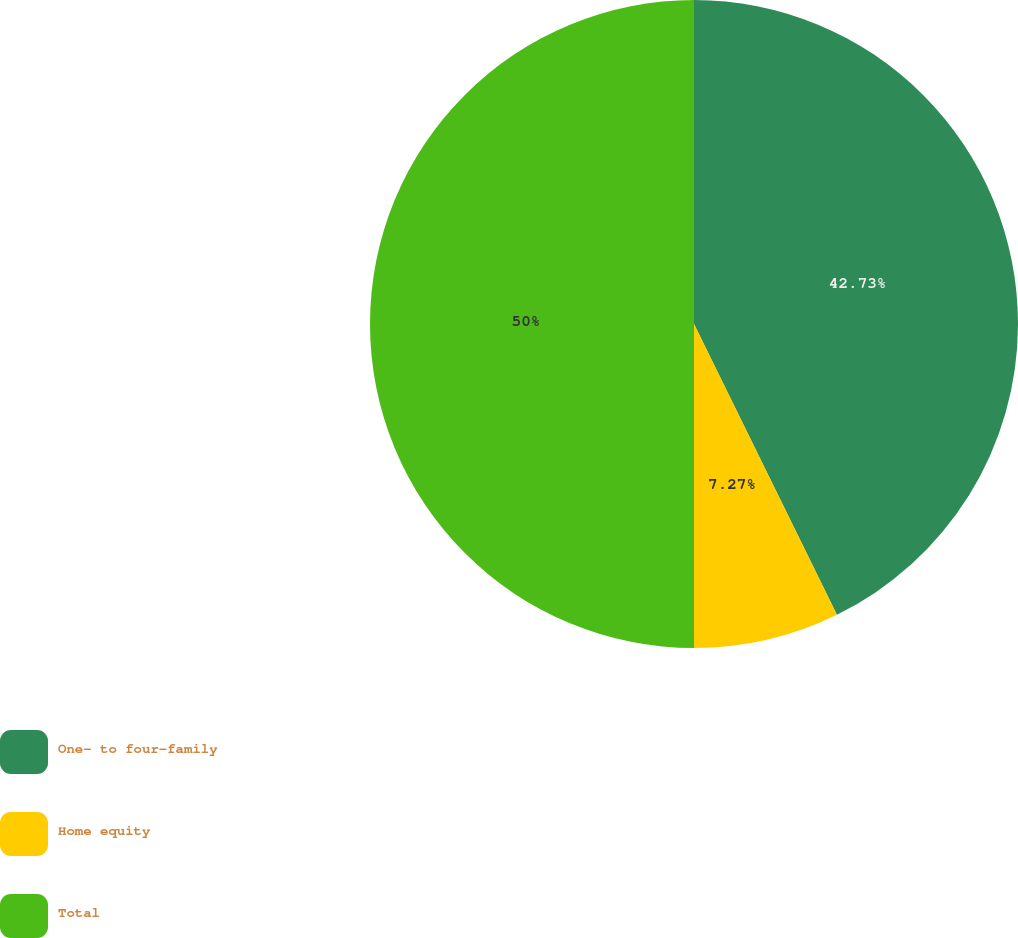Convert chart to OTSL. <chart><loc_0><loc_0><loc_500><loc_500><pie_chart><fcel>One- to four-family<fcel>Home equity<fcel>Total<nl><fcel>42.73%<fcel>7.27%<fcel>50.0%<nl></chart> 